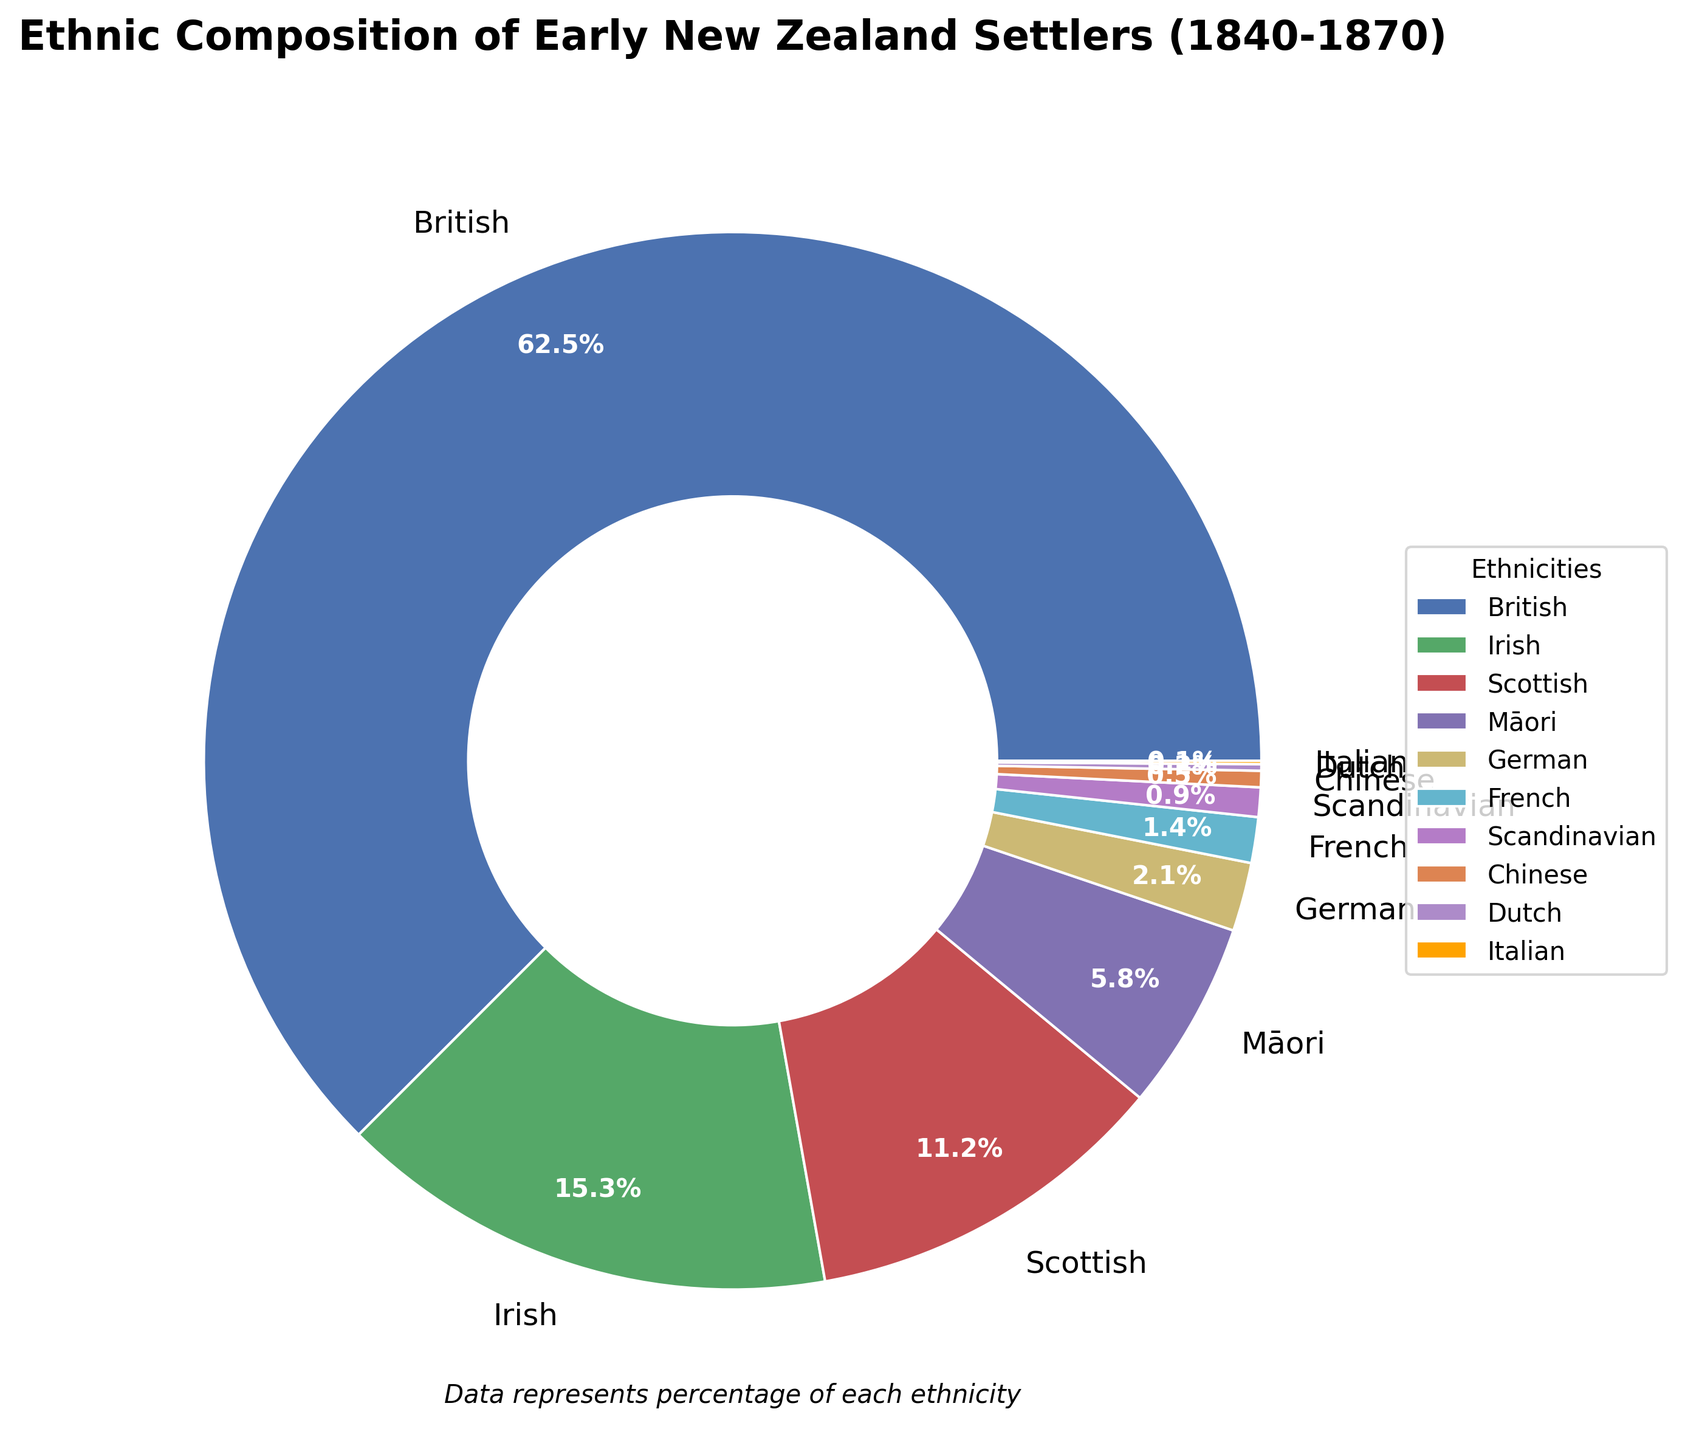What are the top two ethnic groups? The pie chart shows the largest percentages for each ethnicity. By identifying and comparing these values, we notice that the British and Irish groups have the highest percentages. The British are the largest group with 62.5%, followed by the Irish with 15.3%.
Answer: British and Irish Which ethnic group has the smallest representation? By observing the pie chart, the segment representing the smallest percentage belongs to the Italian ethnicity, which is 0.1%.
Answer: Italian What's the combined percentage of the British and Irish settlers? We sum the percentages of the British (62.5%) and Irish (15.3%) settlers. 62.5% + 15.3% results in 77.8%.
Answer: 77.8% How does the percentage of Māori settlers compare to Scottish settlers? By examining the pie chart, the percentage of Māori settlers (5.8%) is compared with the Scottish settlers (11.2%). The Māori percentage is smaller than the Scottish percentage.
Answer: Smaller How many ethnic groups have a representation of less than 1%? By observing the pie chart, we identify the ethnic groups with percentages under 1%. These are Scandinavian (0.9%), Chinese (0.5%), Dutch (0.2%), and Italian (0.1%). There are four such groups.
Answer: 4 What's the difference in percentage points between the Scottish and German settlers? We subtract the percentage of German settlers (2.1%) from that of Scottish settlers (11.2%). This gives us 11.2% - 2.1%, which equals 9.1%.
Answer: 9.1% Which ethnic group has the third-largest representation? According to the pie chart, after the British and Irish, the Scottish group has the third-largest representation at 11.2%.
Answer: Scottish What is the total percentage of settlers from non-British Isles (excluding British, Irish, and Scottish)? We add the percentages of Māori (5.8%), German (2.1%), French (1.4%), Scandinavian (0.9%), Chinese (0.5%), Dutch (0.2%), and Italian (0.1%). This adds up to 10.0%.
Answer: 10.0% Which ethnic group's percentage is closest to that of the Māori settlers? After examining the chart, we see that the German settlers (2.1%) and French settlers (1.4%) have smaller percentages, but the next closest one is German (2.1%). However, it's not very close. No group is close in percentage to the Māori settlers.
Answer: None How are the colors distributed among the ethnic groups with the largest segments? Visually, the largest segment for the British is represented in the first color (blue), followed by the Irish in the second color (green), and then the Scottish in the third color (red).
Answer: Blue for British, Green for Irish, Red for Scottish 